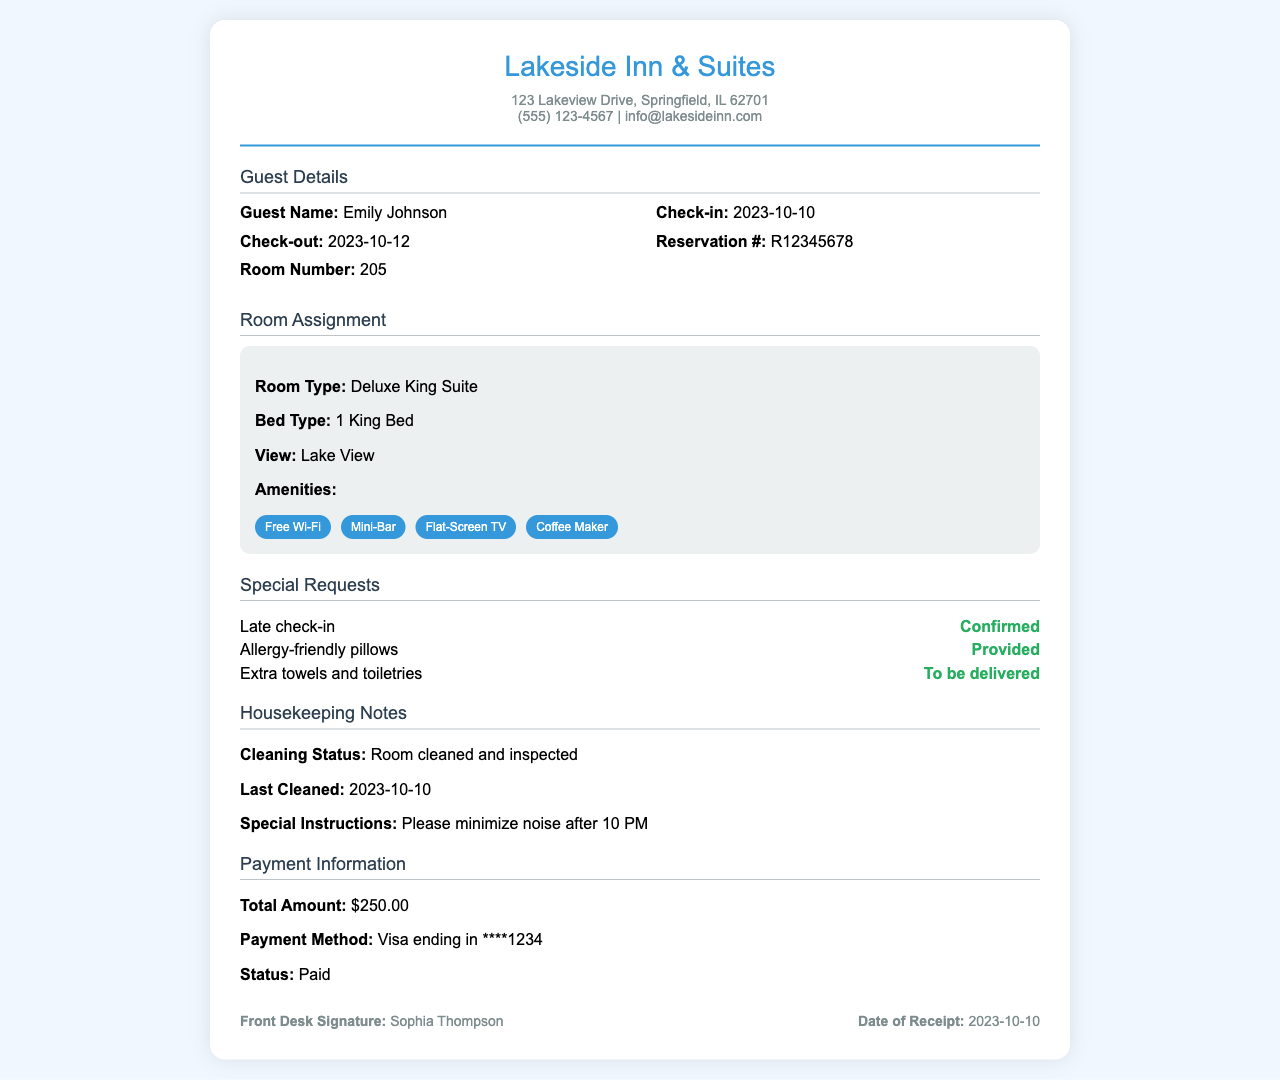what is the guest name? The guest name is listed at the top of the receipt under Guest Details, specifically as "Emily Johnson."
Answer: Emily Johnson what is the reservation number? The reservation number is indicated in the Guest Details section as "R12345678."
Answer: R12345678 what is the room type assigned? The room type is mentioned in the Room Assignment section as "Deluxe King Suite."
Answer: Deluxe King Suite what special request has been confirmed? A special request marked as confirmed is specifically listed as "Late check-in."
Answer: Late check-in what amenities are included in the room? The amenities are detailed in the Room Assignment section, listed as multiple items including "Free Wi-Fi" and "Mini-Bar." The comprehensive list includes all those items.
Answer: Free Wi-Fi, Mini-Bar, Flat-Screen TV, Coffee Maker what is the cleaning status of the room? The cleaning status is specified in the Housekeeping Notes section as "Room cleaned and inspected."
Answer: Room cleaned and inspected what is the total amount for the stay? The total amount is explicitly stated in the Payment Information section as "$250.00."
Answer: $250.00 who signed the receipt from the front desk? The front desk signature is provided at the bottom of the receipt as "Sophia Thompson."
Answer: Sophia Thompson when was the room last cleaned? The last cleaned date is mentioned in the Housekeeping Notes section as "2023-10-10."
Answer: 2023-10-10 